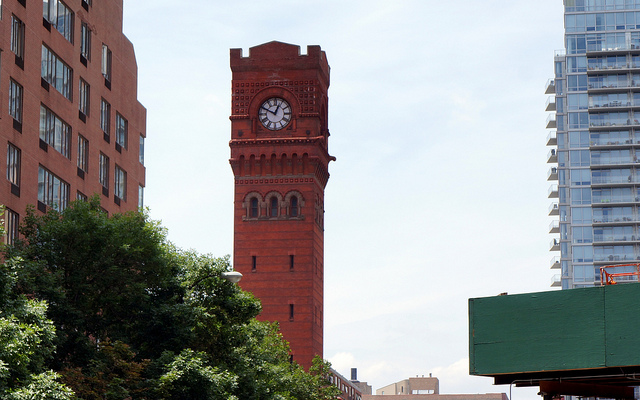What architectural style is represented by the clock tower? The clock tower showcases a Victorian Gothic style, characterized by its intricate façade and the pointed arches of the windows. 